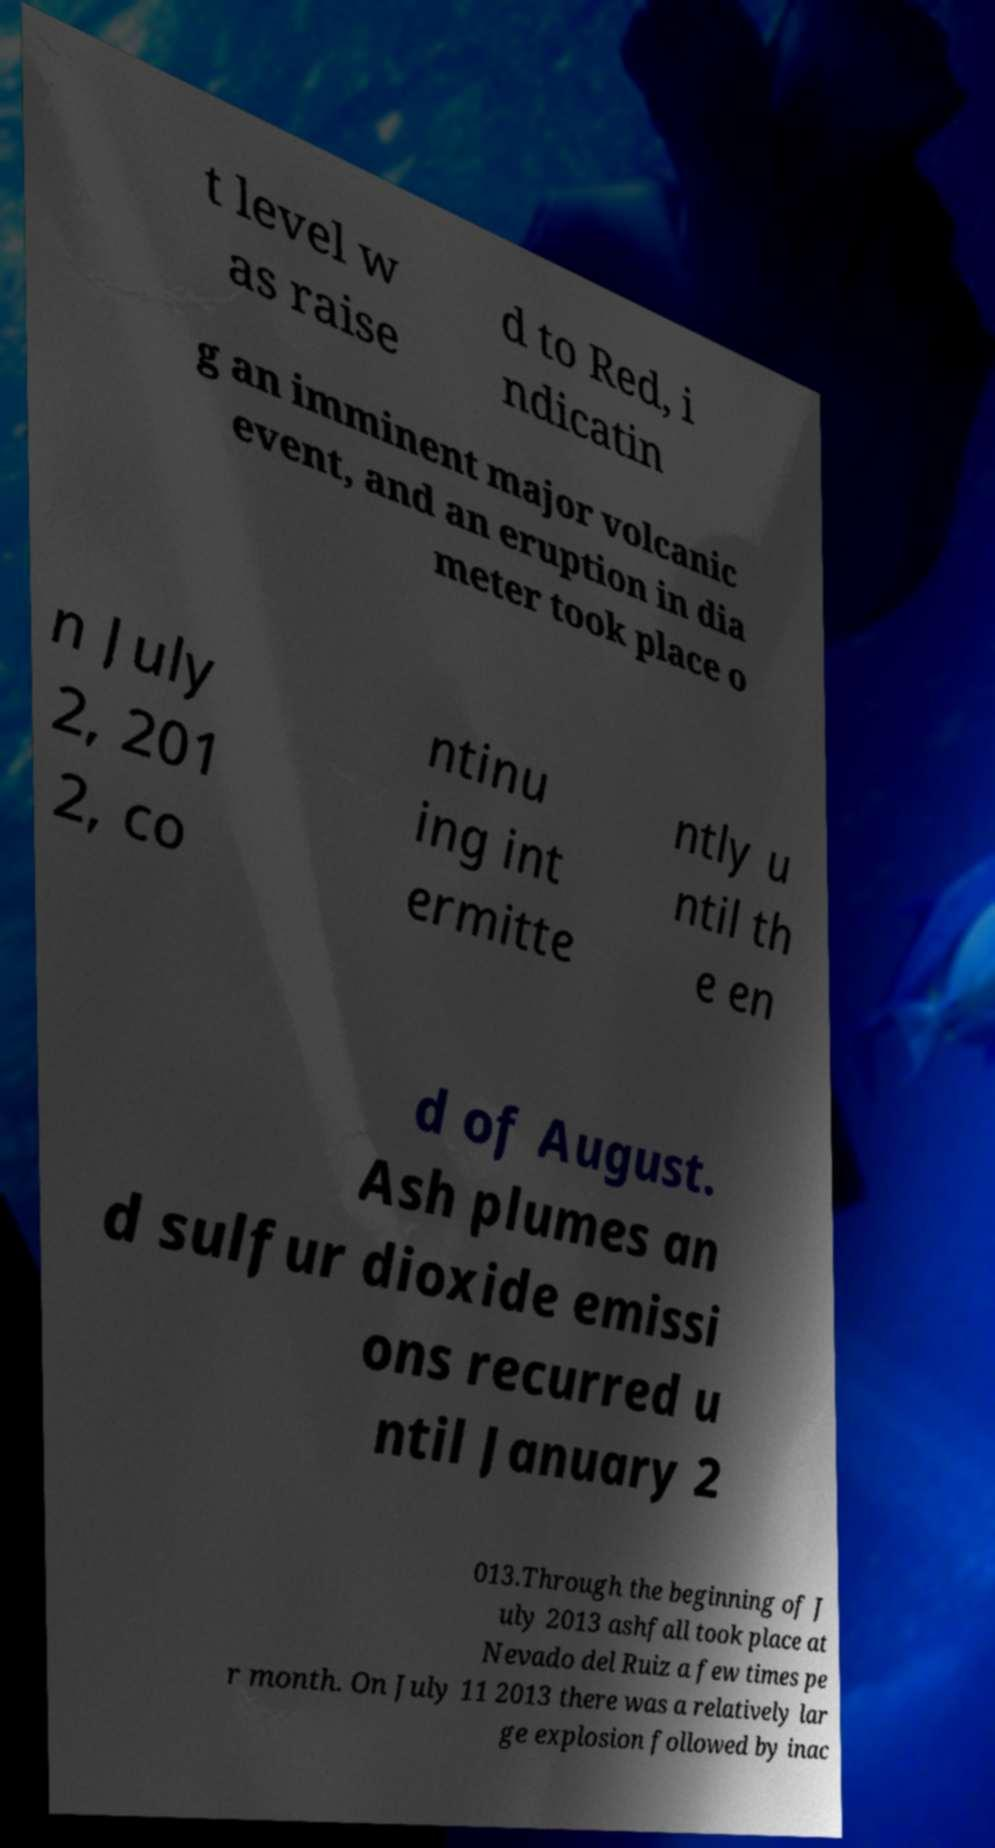Please identify and transcribe the text found in this image. t level w as raise d to Red, i ndicatin g an imminent major volcanic event, and an eruption in dia meter took place o n July 2, 201 2, co ntinu ing int ermitte ntly u ntil th e en d of August. Ash plumes an d sulfur dioxide emissi ons recurred u ntil January 2 013.Through the beginning of J uly 2013 ashfall took place at Nevado del Ruiz a few times pe r month. On July 11 2013 there was a relatively lar ge explosion followed by inac 